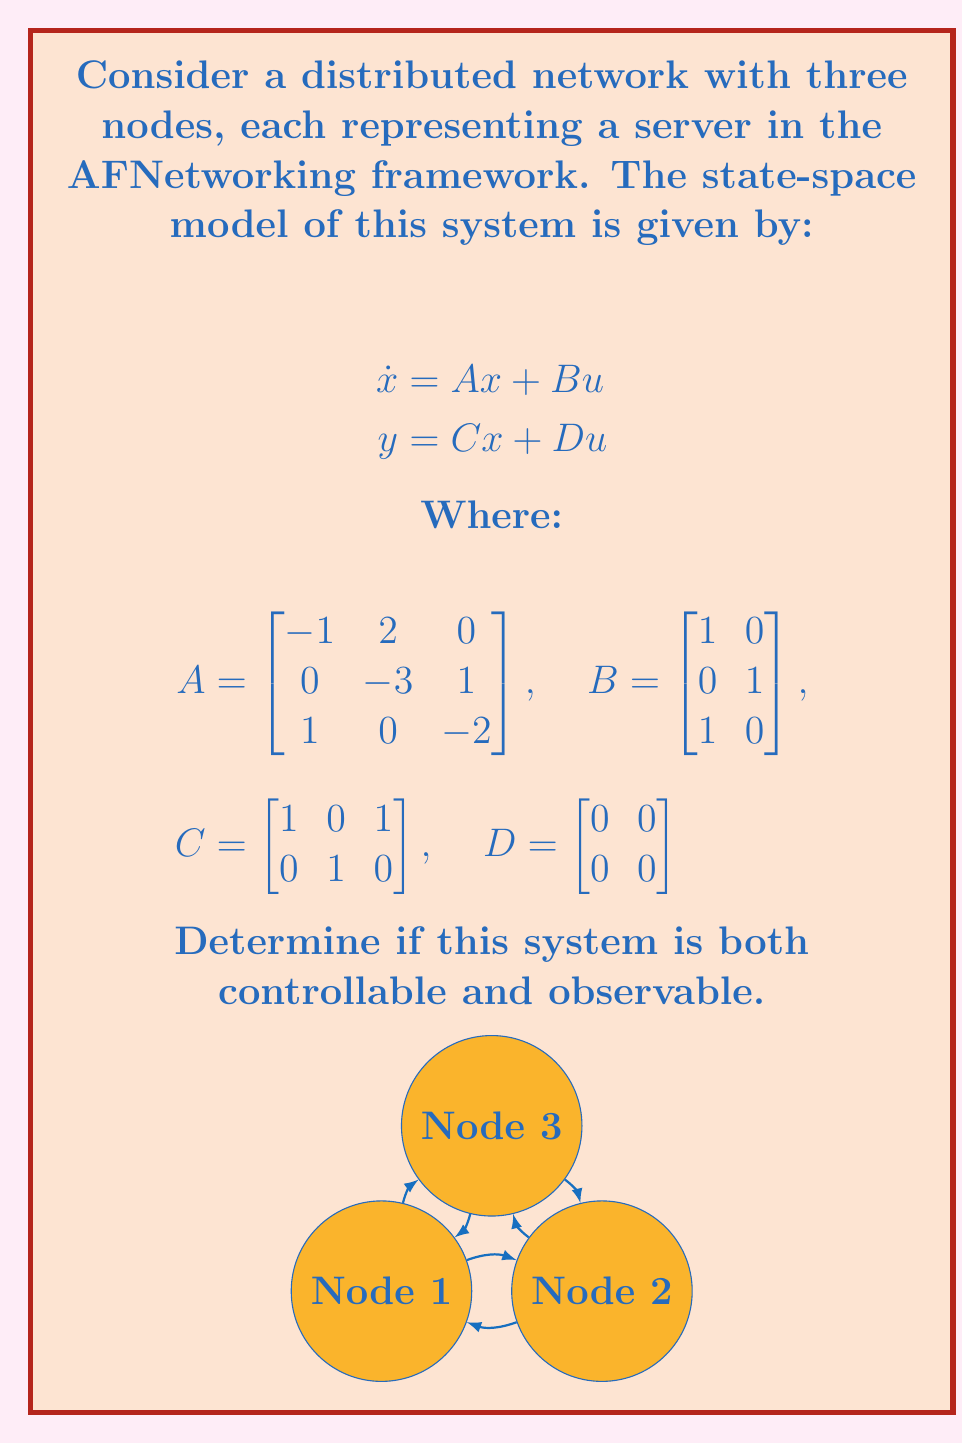Can you solve this math problem? To determine if the system is controllable and observable, we need to check the ranks of the controllability and observability matrices.

1. Controllability:
   The controllability matrix is given by $\mathcal{C} = [B \quad AB \quad A^2B]$

   First, calculate $AB$ and $A^2B$:
   
   $$AB = \begin{bmatrix}
   -1 & 2 \\
   -1 & -3 \\
   0 & -2
   \end{bmatrix}$$

   $$A^2B = \begin{bmatrix}
   -1 & 8 \\
   2 & -7 \\
   -3 & 2
   \end{bmatrix}$$

   Now, form the controllability matrix:

   $$\mathcal{C} = \begin{bmatrix}
   1 & 0 & -1 & 2 & -1 & 8 \\
   0 & 1 & -1 & -3 & 2 & -7 \\
   1 & 0 & 0 & -2 & -3 & 2
   \end{bmatrix}$$

   The rank of $\mathcal{C}$ is 3, which is equal to the number of states. Therefore, the system is controllable.

2. Observability:
   The observability matrix is given by $\mathcal{O} = [C^T \quad (CA)^T \quad (CA^2)^T]$

   First, calculate $CA$ and $CA^2$:

   $$CA = \begin{bmatrix}
   0 & 2 & -2 \\
   0 & -3 & 1
   \end{bmatrix}$$

   $$CA^2 = \begin{bmatrix}
   -1 & -4 & 3 \\
   0 & 9 & -3
   \end{bmatrix}$$

   Now, form the observability matrix:

   $$\mathcal{O} = \begin{bmatrix}
   1 & 0 & 1 \\
   0 & 1 & 0 \\
   0 & 2 & -2 \\
   0 & -3 & 1 \\
   -1 & -4 & 3 \\
   0 & 9 & -3
   \end{bmatrix}$$

   The rank of $\mathcal{O}$ is 3, which is equal to the number of states. Therefore, the system is observable.
Answer: The system is both controllable and observable. 